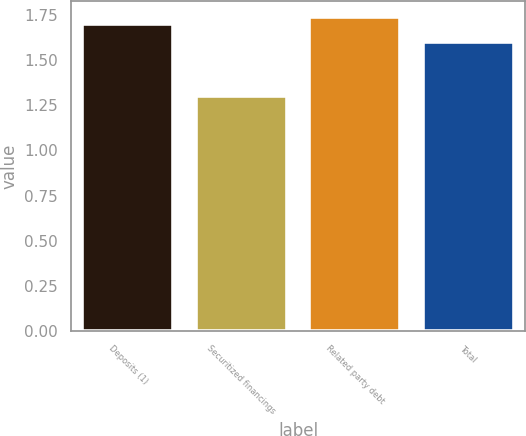Convert chart. <chart><loc_0><loc_0><loc_500><loc_500><bar_chart><fcel>Deposits (1)<fcel>Securitized financings<fcel>Related party debt<fcel>Total<nl><fcel>1.7<fcel>1.3<fcel>1.74<fcel>1.6<nl></chart> 